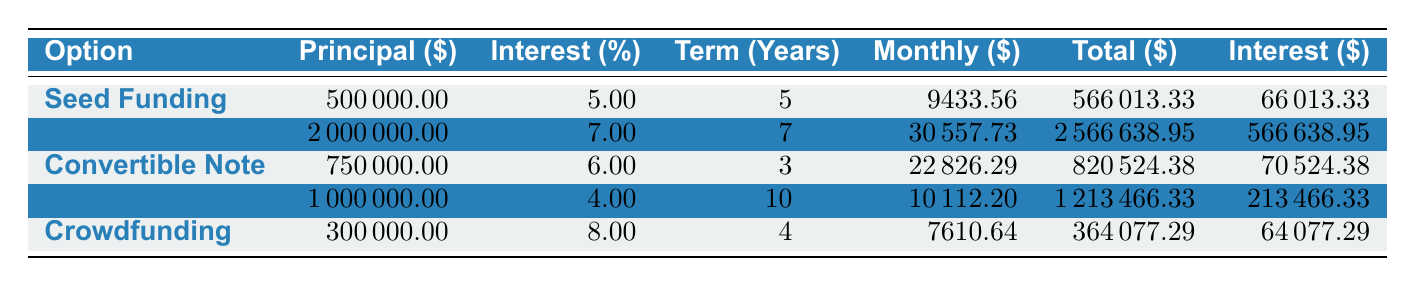What is the monthly payment for Venture Capital? From the table, under the "Venture Capital" row, the "Monthly" column lists the amount as 30557.73.
Answer: 30557.73 What is the total interest paid for the Seed Funding option? The "Total Interest" column for "Seed Funding" indicates 66013.33.
Answer: 66013.33 How much less is the total payment of the Bank Loan compared to the Venture Capital? The total payment for the Bank Loan is 1213466.33 and for Venture Capital, it is 2566638.95. The difference is 2566638.95 - 1213466.33 = 1353172.62.
Answer: 1353172.62 Is the interest rate for the Convertible Note higher than that of the Bank Loan? The interest rate for Convertible Note is 6.00%, while for Bank Loan, it is 4.00%. Since 6.00% is greater than 4.00%, the answer is yes.
Answer: Yes What is the average total payment for all financing options listed? The total payments are: 566013.33, 2566638.95, 820524.38, 1213466.33, 364077.29. Their sum is 566013.33 + 2566638.95 + 820524.38 + 1213466.33 + 364077.29 = 4420720.28. Dividing by 5 (the number of options) gives 4420720.28 / 5 = 884144.06.
Answer: 884144.06 What is the principal amount for the Crowdfunding option? Under the "Crowdfunding" row, the "Principal" column indicates an amount of 300000.00.
Answer: 300000.00 How does the total payment for Seed Funding compare to the total payment for Convertible Note? The total payments are 566013.33 for Seed Funding and 820524.38 for Convertible Note. 820524.38 - 566013.33 = 254511.05, indicating that Convertible Note's total payment is higher.
Answer: Convertible Note is higher by 254511.05 Is the total interest paid for Crowdfunding less than for Seed Funding? The total interest for Crowdfunding is 64077.29 and for Seed Funding, it is 66013.33. Since 64077.29 is less than 66013.33, the answer is yes.
Answer: Yes Which option has the highest total payment? Comparing total payments: 566013.33 (Seed Funding), 2566638.95 (Venture Capital), 820524.38 (Convertible Note), 1213466.33 (Bank Loan), 364077.29 (Crowdfunding), the highest is 2566638.95 for Venture Capital.
Answer: Venture Capital 